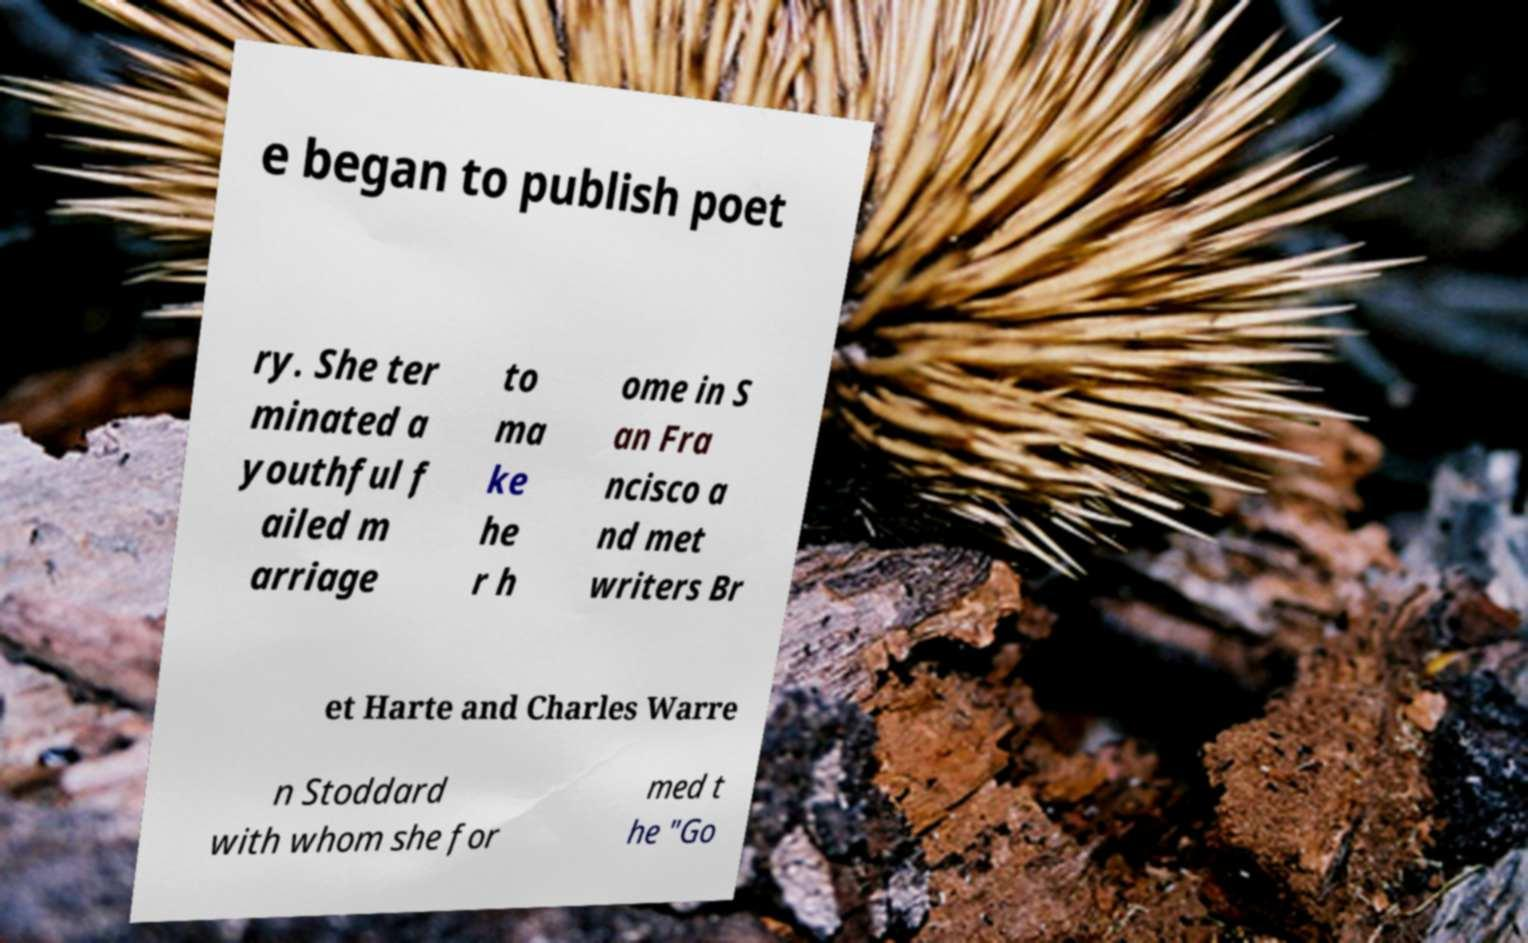Can you accurately transcribe the text from the provided image for me? e began to publish poet ry. She ter minated a youthful f ailed m arriage to ma ke he r h ome in S an Fra ncisco a nd met writers Br et Harte and Charles Warre n Stoddard with whom she for med t he "Go 